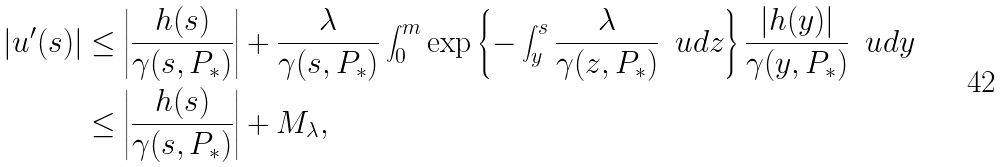Convert formula to latex. <formula><loc_0><loc_0><loc_500><loc_500>| u ^ { \prime } ( s ) | & \leq \left | \frac { h ( s ) } { \gamma ( s , P _ { * } ) } \right | + \frac { \lambda } { \gamma ( s , P _ { * } ) } \int _ { 0 } ^ { m } \exp \left \{ - \int _ { y } ^ { s } \frac { \lambda } { \gamma ( z , P _ { * } ) } \, \ u d z \right \} \frac { | h ( y ) | } { \gamma ( y , P _ { * } ) } \, \ u d y \\ & \leq \left | \frac { h ( s ) } { \gamma ( s , P _ { * } ) } \right | + M _ { \lambda } ,</formula> 